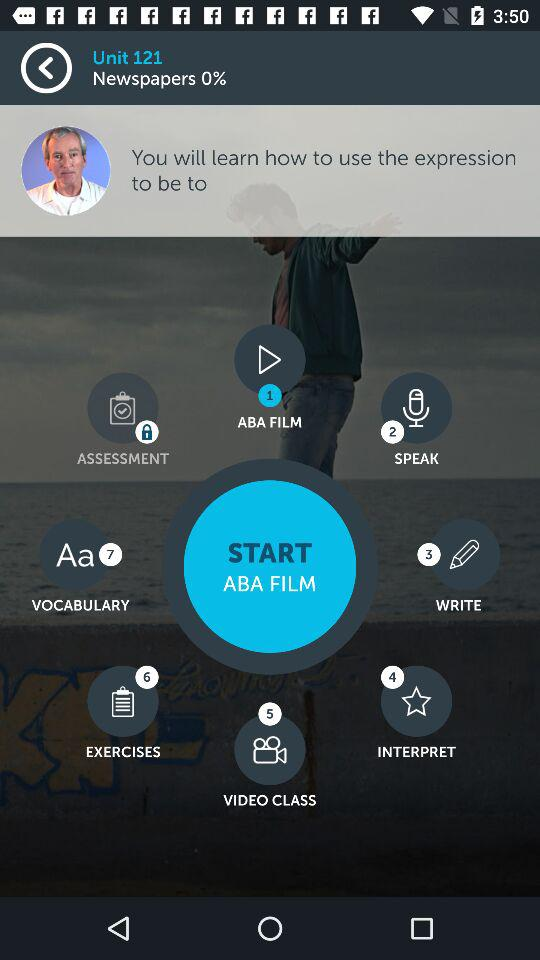What is the unit number shown in the application? The unit number shown in the application is 121. 